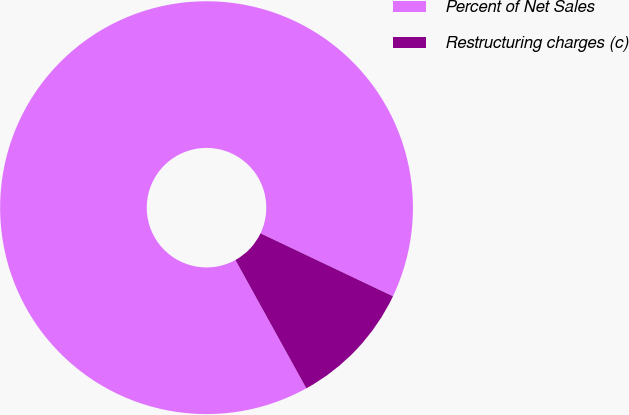Convert chart to OTSL. <chart><loc_0><loc_0><loc_500><loc_500><pie_chart><fcel>Percent of Net Sales<fcel>Restructuring charges (c)<nl><fcel>90.09%<fcel>9.91%<nl></chart> 